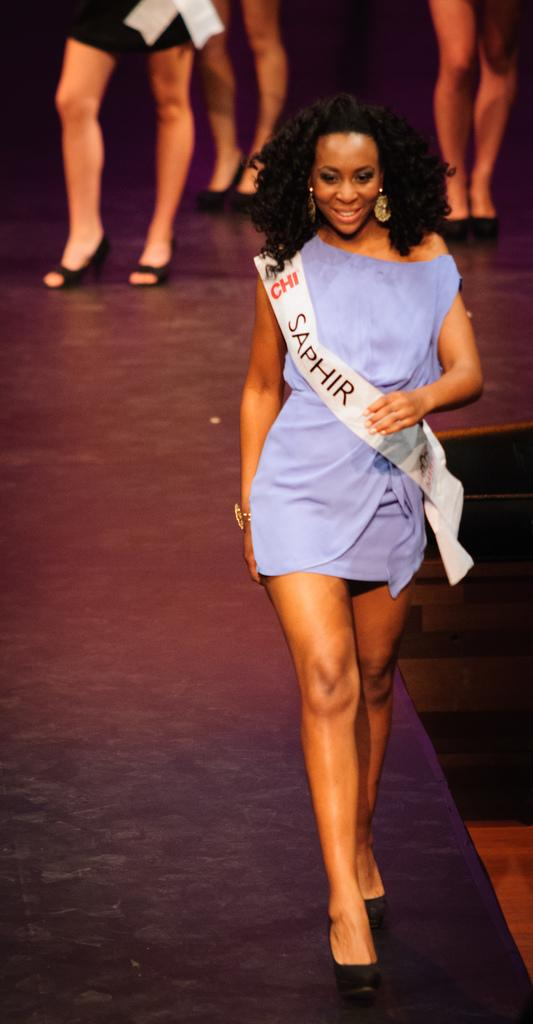<image>
Provide a brief description of the given image. A woman in a blue dress is wearing a sash that says SAPHIR on it. 